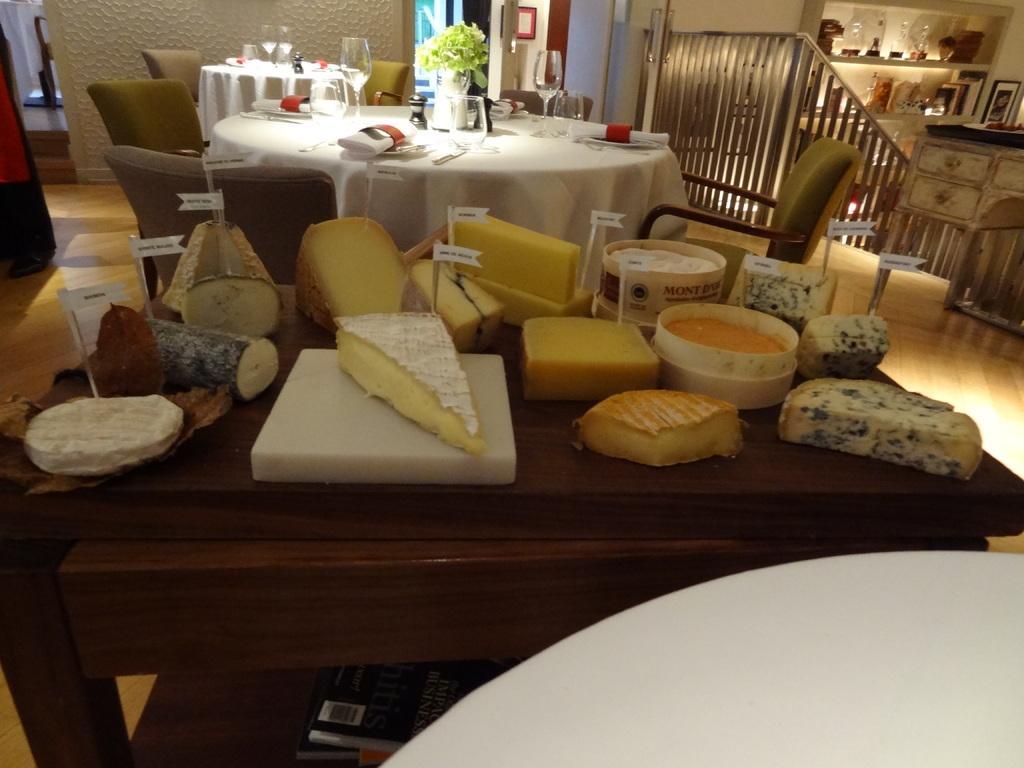Can you describe this image briefly? In this picture we can observe a brown color table on which there is some food. We can observe some fruits on the table. There is a white color table on which there is a small plant, plates and tissues were placed. There are some chairs around these white tables. On the right side there is a railing and stairs. In the background there is a wall. 